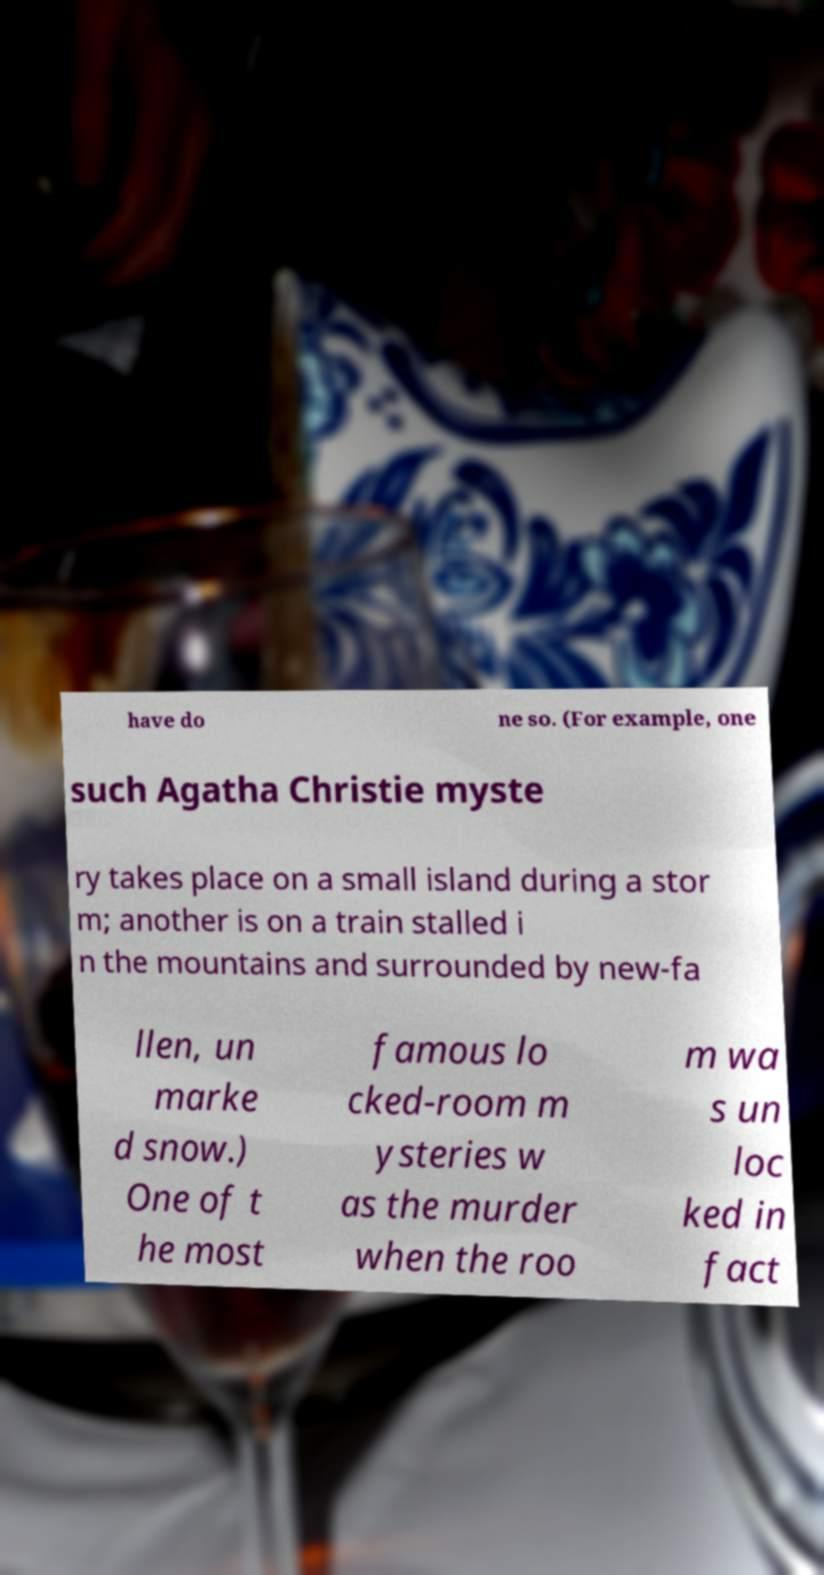For documentation purposes, I need the text within this image transcribed. Could you provide that? have do ne so. (For example, one such Agatha Christie myste ry takes place on a small island during a stor m; another is on a train stalled i n the mountains and surrounded by new-fa llen, un marke d snow.) One of t he most famous lo cked-room m ysteries w as the murder when the roo m wa s un loc ked in fact 